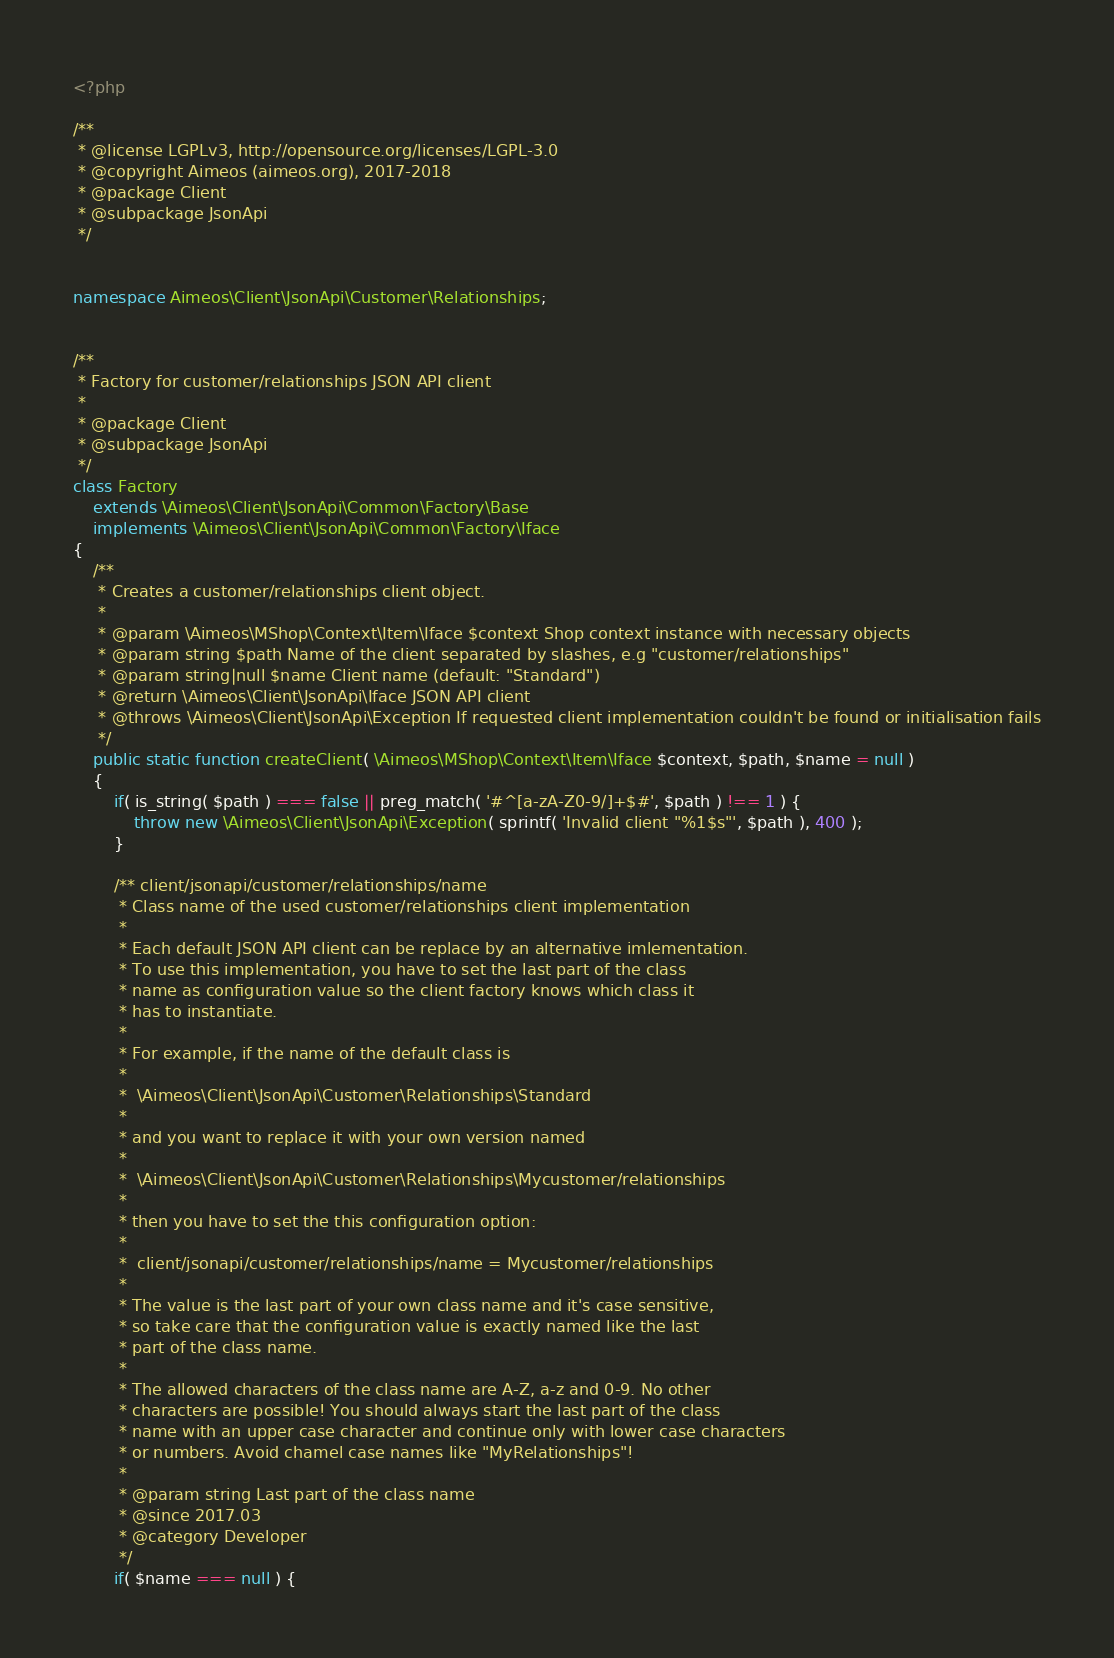<code> <loc_0><loc_0><loc_500><loc_500><_PHP_><?php

/**
 * @license LGPLv3, http://opensource.org/licenses/LGPL-3.0
 * @copyright Aimeos (aimeos.org), 2017-2018
 * @package Client
 * @subpackage JsonApi
 */


namespace Aimeos\Client\JsonApi\Customer\Relationships;


/**
 * Factory for customer/relationships JSON API client
 *
 * @package Client
 * @subpackage JsonApi
 */
class Factory
	extends \Aimeos\Client\JsonApi\Common\Factory\Base
	implements \Aimeos\Client\JsonApi\Common\Factory\Iface
{
	/**
	 * Creates a customer/relationships client object.
	 *
	 * @param \Aimeos\MShop\Context\Item\Iface $context Shop context instance with necessary objects
	 * @param string $path Name of the client separated by slashes, e.g "customer/relationships"
	 * @param string|null $name Client name (default: "Standard")
	 * @return \Aimeos\Client\JsonApi\Iface JSON API client
	 * @throws \Aimeos\Client\JsonApi\Exception If requested client implementation couldn't be found or initialisation fails
	 */
	public static function createClient( \Aimeos\MShop\Context\Item\Iface $context, $path, $name = null )
	{
		if( is_string( $path ) === false || preg_match( '#^[a-zA-Z0-9/]+$#', $path ) !== 1 ) {
			throw new \Aimeos\Client\JsonApi\Exception( sprintf( 'Invalid client "%1$s"', $path ), 400 );
		}

		/** client/jsonapi/customer/relationships/name
		 * Class name of the used customer/relationships client implementation
		 *
		 * Each default JSON API client can be replace by an alternative imlementation.
		 * To use this implementation, you have to set the last part of the class
		 * name as configuration value so the client factory knows which class it
		 * has to instantiate.
		 *
		 * For example, if the name of the default class is
		 *
		 *  \Aimeos\Client\JsonApi\Customer\Relationships\Standard
		 *
		 * and you want to replace it with your own version named
		 *
		 *  \Aimeos\Client\JsonApi\Customer\Relationships\Mycustomer/relationships
		 *
		 * then you have to set the this configuration option:
		 *
		 *  client/jsonapi/customer/relationships/name = Mycustomer/relationships
		 *
		 * The value is the last part of your own class name and it's case sensitive,
		 * so take care that the configuration value is exactly named like the last
		 * part of the class name.
		 *
		 * The allowed characters of the class name are A-Z, a-z and 0-9. No other
		 * characters are possible! You should always start the last part of the class
		 * name with an upper case character and continue only with lower case characters
		 * or numbers. Avoid chamel case names like "MyRelationships"!
		 *
		 * @param string Last part of the class name
		 * @since 2017.03
		 * @category Developer
		 */
		if( $name === null ) {</code> 